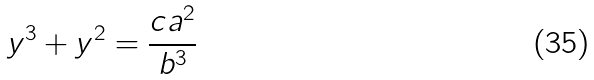Convert formula to latex. <formula><loc_0><loc_0><loc_500><loc_500>y ^ { 3 } + y ^ { 2 } = { \frac { c a ^ { 2 } } { b ^ { 3 } } }</formula> 